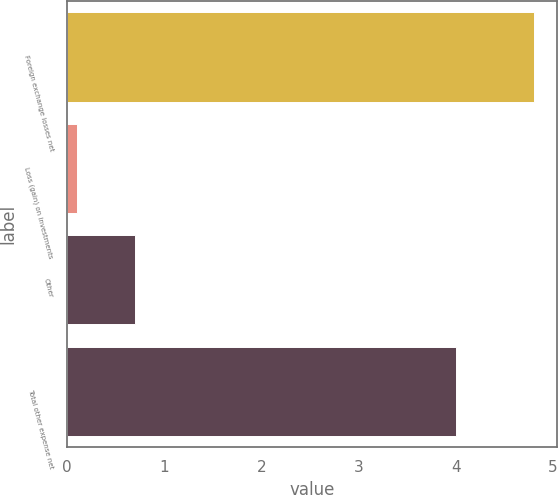Convert chart to OTSL. <chart><loc_0><loc_0><loc_500><loc_500><bar_chart><fcel>Foreign exchange losses net<fcel>Loss (gain) on investments<fcel>Other<fcel>Total other expense net<nl><fcel>4.8<fcel>0.1<fcel>0.7<fcel>4<nl></chart> 